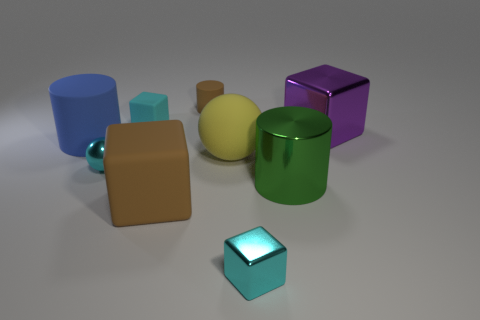Subtract all brown balls. How many cyan blocks are left? 2 Subtract all small cyan rubber cubes. How many cubes are left? 3 Subtract 1 cylinders. How many cylinders are left? 2 Subtract all brown cubes. How many cubes are left? 3 Add 1 cylinders. How many objects exist? 10 Subtract all cylinders. How many objects are left? 6 Subtract all yellow cubes. Subtract all cyan cylinders. How many cubes are left? 4 Add 2 small cyan shiny blocks. How many small cyan shiny blocks are left? 3 Add 5 small brown matte cylinders. How many small brown matte cylinders exist? 6 Subtract 0 gray cubes. How many objects are left? 9 